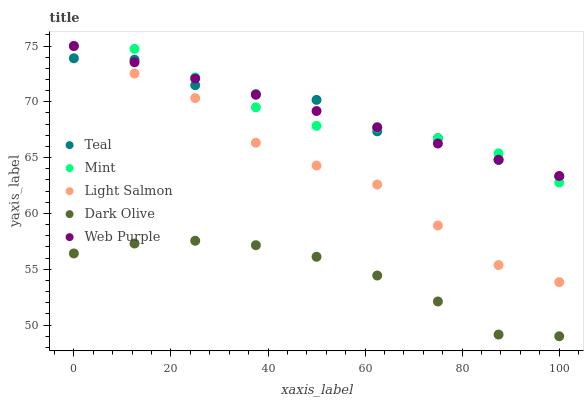Does Dark Olive have the minimum area under the curve?
Answer yes or no. Yes. Does Teal have the maximum area under the curve?
Answer yes or no. Yes. Does Mint have the minimum area under the curve?
Answer yes or no. No. Does Mint have the maximum area under the curve?
Answer yes or no. No. Is Web Purple the smoothest?
Answer yes or no. Yes. Is Teal the roughest?
Answer yes or no. Yes. Is Dark Olive the smoothest?
Answer yes or no. No. Is Dark Olive the roughest?
Answer yes or no. No. Does Dark Olive have the lowest value?
Answer yes or no. Yes. Does Mint have the lowest value?
Answer yes or no. No. Does Web Purple have the highest value?
Answer yes or no. Yes. Does Dark Olive have the highest value?
Answer yes or no. No. Is Dark Olive less than Web Purple?
Answer yes or no. Yes. Is Teal greater than Dark Olive?
Answer yes or no. Yes. Does Web Purple intersect Light Salmon?
Answer yes or no. Yes. Is Web Purple less than Light Salmon?
Answer yes or no. No. Is Web Purple greater than Light Salmon?
Answer yes or no. No. Does Dark Olive intersect Web Purple?
Answer yes or no. No. 